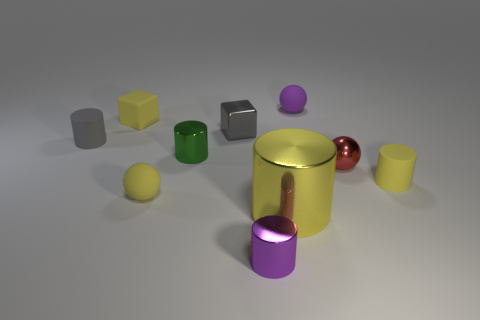How many yellow cylinders must be subtracted to get 1 yellow cylinders? 1 Subtract all tiny purple matte spheres. How many spheres are left? 2 Subtract all brown blocks. How many yellow cylinders are left? 2 Subtract 1 spheres. How many spheres are left? 2 Subtract all yellow spheres. How many spheres are left? 2 Subtract all gray balls. Subtract all yellow blocks. How many balls are left? 3 Subtract 0 cyan cylinders. How many objects are left? 10 Subtract all blocks. How many objects are left? 8 Subtract all tiny green shiny cylinders. Subtract all tiny yellow matte blocks. How many objects are left? 8 Add 4 gray shiny objects. How many gray shiny objects are left? 5 